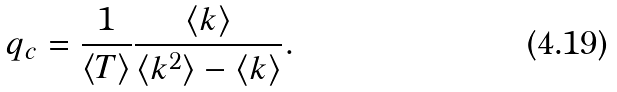Convert formula to latex. <formula><loc_0><loc_0><loc_500><loc_500>q _ { c } = \frac { 1 } { \langle T \rangle } \frac { \langle k \rangle } { \langle k ^ { 2 } \rangle - \langle k \rangle } .</formula> 